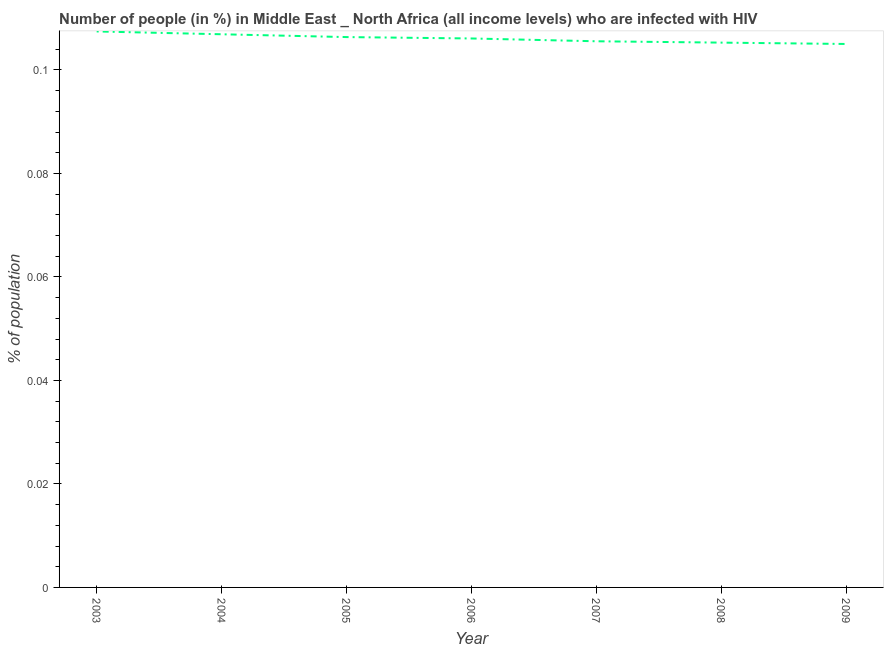What is the number of people infected with hiv in 2004?
Offer a terse response. 0.11. Across all years, what is the maximum number of people infected with hiv?
Give a very brief answer. 0.11. Across all years, what is the minimum number of people infected with hiv?
Provide a succinct answer. 0.11. In which year was the number of people infected with hiv maximum?
Your response must be concise. 2003. In which year was the number of people infected with hiv minimum?
Your response must be concise. 2009. What is the sum of the number of people infected with hiv?
Provide a succinct answer. 0.74. What is the difference between the number of people infected with hiv in 2004 and 2009?
Provide a succinct answer. 0. What is the average number of people infected with hiv per year?
Your response must be concise. 0.11. What is the median number of people infected with hiv?
Provide a short and direct response. 0.11. In how many years, is the number of people infected with hiv greater than 0.02 %?
Your response must be concise. 7. What is the ratio of the number of people infected with hiv in 2005 to that in 2008?
Give a very brief answer. 1.01. Is the difference between the number of people infected with hiv in 2003 and 2009 greater than the difference between any two years?
Make the answer very short. Yes. What is the difference between the highest and the second highest number of people infected with hiv?
Your response must be concise. 0. What is the difference between the highest and the lowest number of people infected with hiv?
Make the answer very short. 0. Does the number of people infected with hiv monotonically increase over the years?
Offer a very short reply. No. What is the difference between two consecutive major ticks on the Y-axis?
Keep it short and to the point. 0.02. Does the graph contain any zero values?
Give a very brief answer. No. What is the title of the graph?
Ensure brevity in your answer.  Number of people (in %) in Middle East _ North Africa (all income levels) who are infected with HIV. What is the label or title of the X-axis?
Make the answer very short. Year. What is the label or title of the Y-axis?
Provide a short and direct response. % of population. What is the % of population in 2003?
Provide a short and direct response. 0.11. What is the % of population of 2004?
Make the answer very short. 0.11. What is the % of population in 2005?
Your answer should be very brief. 0.11. What is the % of population of 2006?
Give a very brief answer. 0.11. What is the % of population in 2007?
Your answer should be very brief. 0.11. What is the % of population in 2008?
Ensure brevity in your answer.  0.11. What is the % of population of 2009?
Give a very brief answer. 0.11. What is the difference between the % of population in 2003 and 2004?
Provide a short and direct response. 0. What is the difference between the % of population in 2003 and 2005?
Ensure brevity in your answer.  0. What is the difference between the % of population in 2003 and 2006?
Offer a very short reply. 0. What is the difference between the % of population in 2003 and 2007?
Your response must be concise. 0. What is the difference between the % of population in 2003 and 2008?
Make the answer very short. 0. What is the difference between the % of population in 2003 and 2009?
Give a very brief answer. 0. What is the difference between the % of population in 2004 and 2005?
Your answer should be very brief. 0. What is the difference between the % of population in 2004 and 2006?
Give a very brief answer. 0. What is the difference between the % of population in 2004 and 2007?
Give a very brief answer. 0. What is the difference between the % of population in 2004 and 2008?
Give a very brief answer. 0. What is the difference between the % of population in 2004 and 2009?
Provide a short and direct response. 0. What is the difference between the % of population in 2005 and 2006?
Your response must be concise. 0. What is the difference between the % of population in 2005 and 2007?
Give a very brief answer. 0. What is the difference between the % of population in 2005 and 2008?
Provide a succinct answer. 0. What is the difference between the % of population in 2005 and 2009?
Ensure brevity in your answer.  0. What is the difference between the % of population in 2006 and 2007?
Ensure brevity in your answer.  0. What is the difference between the % of population in 2006 and 2008?
Give a very brief answer. 0. What is the difference between the % of population in 2006 and 2009?
Your response must be concise. 0. What is the difference between the % of population in 2007 and 2008?
Make the answer very short. 0. What is the difference between the % of population in 2007 and 2009?
Give a very brief answer. 0. What is the difference between the % of population in 2008 and 2009?
Give a very brief answer. 0. What is the ratio of the % of population in 2003 to that in 2006?
Provide a succinct answer. 1.01. What is the ratio of the % of population in 2003 to that in 2007?
Your response must be concise. 1.02. What is the ratio of the % of population in 2003 to that in 2009?
Offer a very short reply. 1.02. What is the ratio of the % of population in 2004 to that in 2006?
Keep it short and to the point. 1.01. What is the ratio of the % of population in 2005 to that in 2006?
Your response must be concise. 1. What is the ratio of the % of population in 2005 to that in 2008?
Your answer should be very brief. 1.01. What is the ratio of the % of population in 2005 to that in 2009?
Provide a short and direct response. 1.01. What is the ratio of the % of population in 2006 to that in 2007?
Your answer should be compact. 1. What is the ratio of the % of population in 2006 to that in 2009?
Offer a very short reply. 1.01. What is the ratio of the % of population in 2007 to that in 2008?
Provide a succinct answer. 1. What is the ratio of the % of population in 2007 to that in 2009?
Offer a terse response. 1. What is the ratio of the % of population in 2008 to that in 2009?
Provide a succinct answer. 1. 